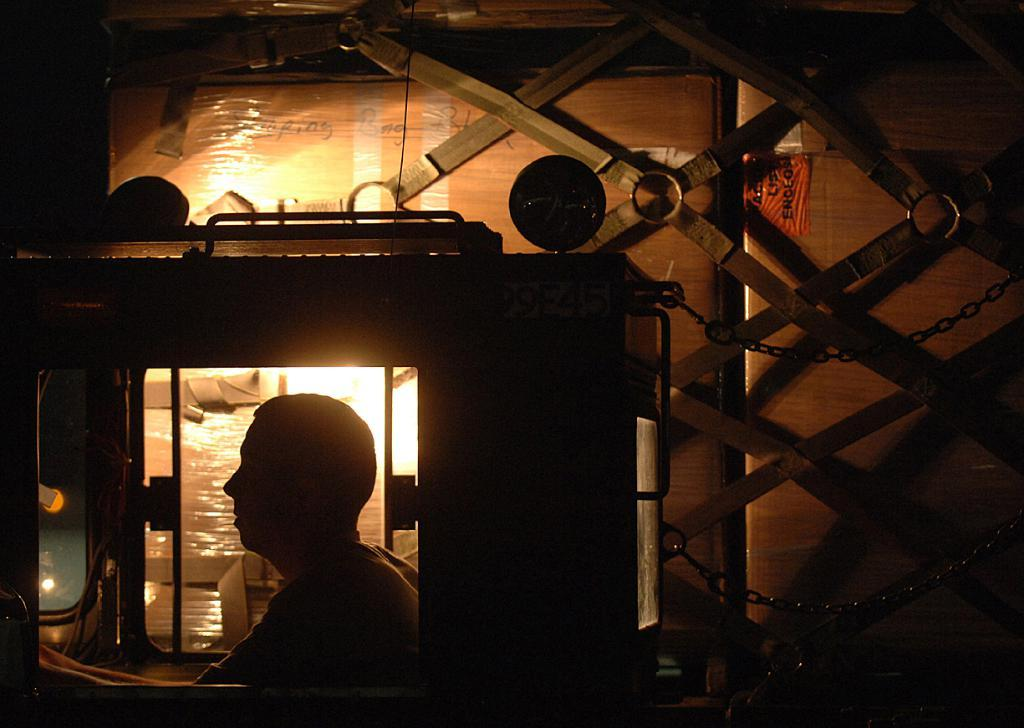What is the overall lighting condition of the image? The image is dark. What is the person in the image doing? There is a person sitting in the image. What type of restraints are visible in the image? Chains are visible in the image. What type of accessory is present in the image? Belts are present in the image. What can be seen in the background of the image? There is light visible in the background of the image. What type of account is the person in the image trying to open? There is no indication of an account or any financial activity in the image. How does the person in the image rub their hands together? There is no rubbing of hands visible in the image. 